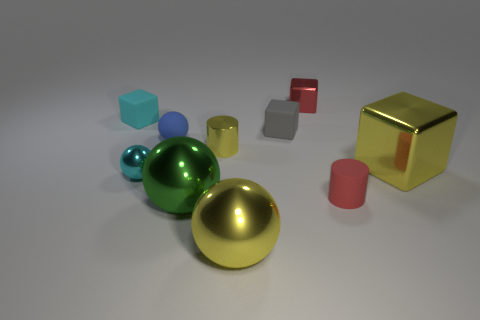Are there any other things that have the same size as the shiny cylinder?
Make the answer very short. Yes. Does the yellow thing on the right side of the tiny gray rubber block have the same material as the cylinder left of the tiny gray matte block?
Offer a terse response. Yes. What number of cyan blocks are the same size as the red matte thing?
Your answer should be very brief. 1. The tiny object that is the same color as the tiny metallic cube is what shape?
Your answer should be compact. Cylinder. What is the material of the small cyan thing in front of the big metallic block?
Give a very brief answer. Metal. How many tiny metal things are the same shape as the tiny blue rubber object?
Offer a very short reply. 1. What shape is the tiny blue object that is the same material as the small gray cube?
Offer a terse response. Sphere. There is a tiny red thing in front of the yellow metallic cylinder on the right side of the cyan thing behind the blue ball; what is its shape?
Offer a very short reply. Cylinder. Are there more cylinders than yellow things?
Your answer should be compact. No. There is a cyan object that is the same shape as the tiny gray matte object; what is it made of?
Give a very brief answer. Rubber. 